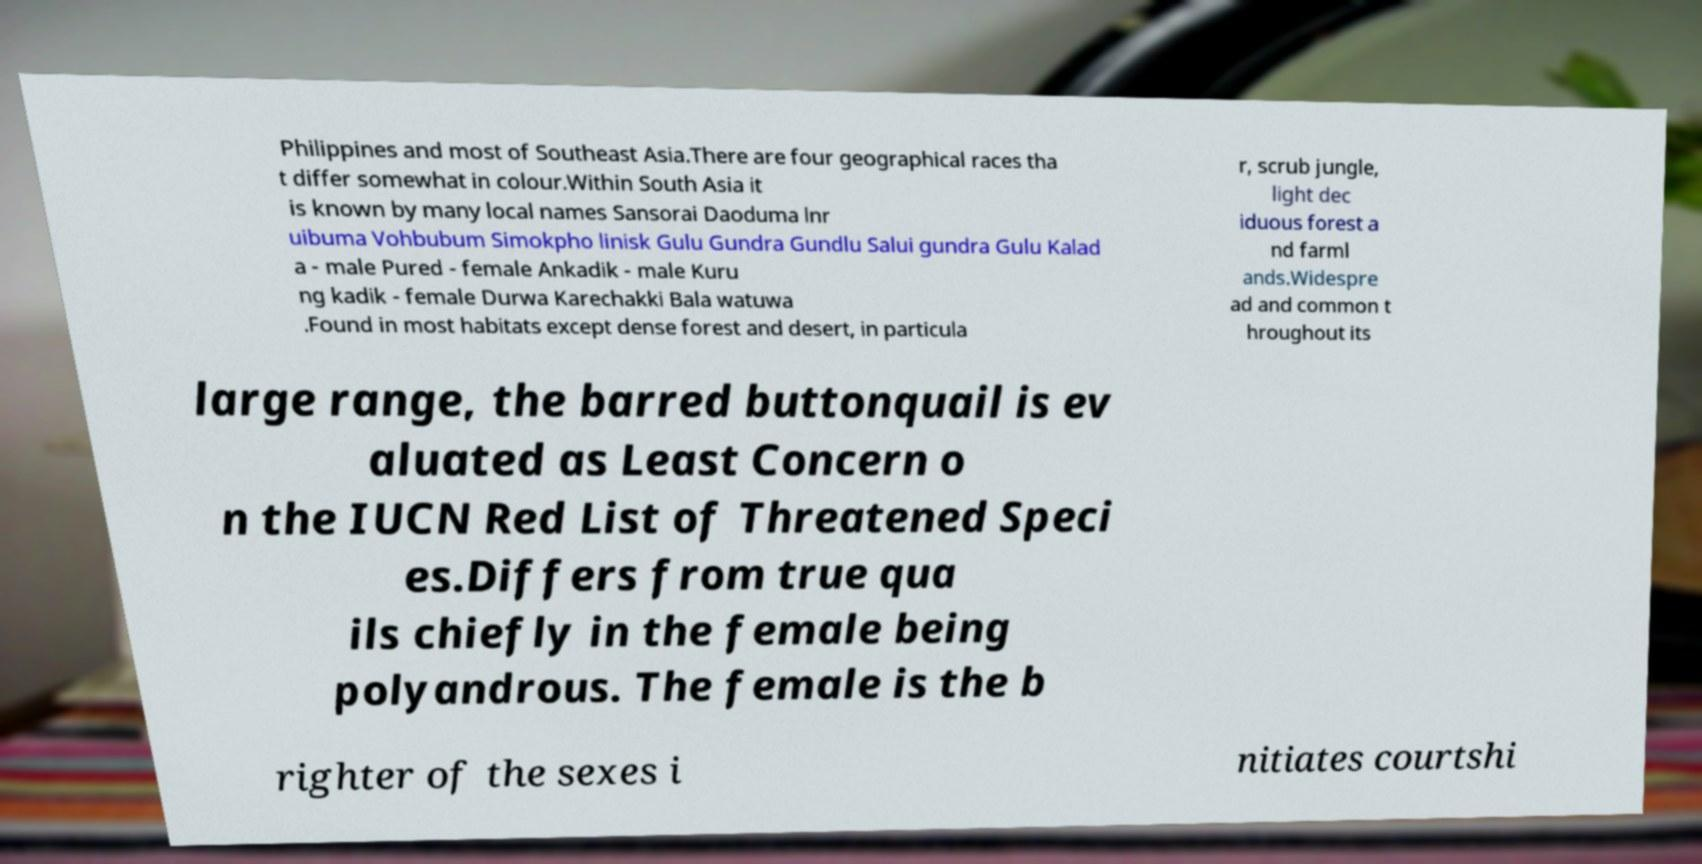For documentation purposes, I need the text within this image transcribed. Could you provide that? Philippines and most of Southeast Asia.There are four geographical races tha t differ somewhat in colour.Within South Asia it is known by many local names Sansorai Daoduma lnr uibuma Vohbubum Simokpho linisk Gulu Gundra Gundlu Salui gundra Gulu Kalad a - male Pured - female Ankadik - male Kuru ng kadik - female Durwa Karechakki Bala watuwa .Found in most habitats except dense forest and desert, in particula r, scrub jungle, light dec iduous forest a nd farml ands.Widespre ad and common t hroughout its large range, the barred buttonquail is ev aluated as Least Concern o n the IUCN Red List of Threatened Speci es.Differs from true qua ils chiefly in the female being polyandrous. The female is the b righter of the sexes i nitiates courtshi 